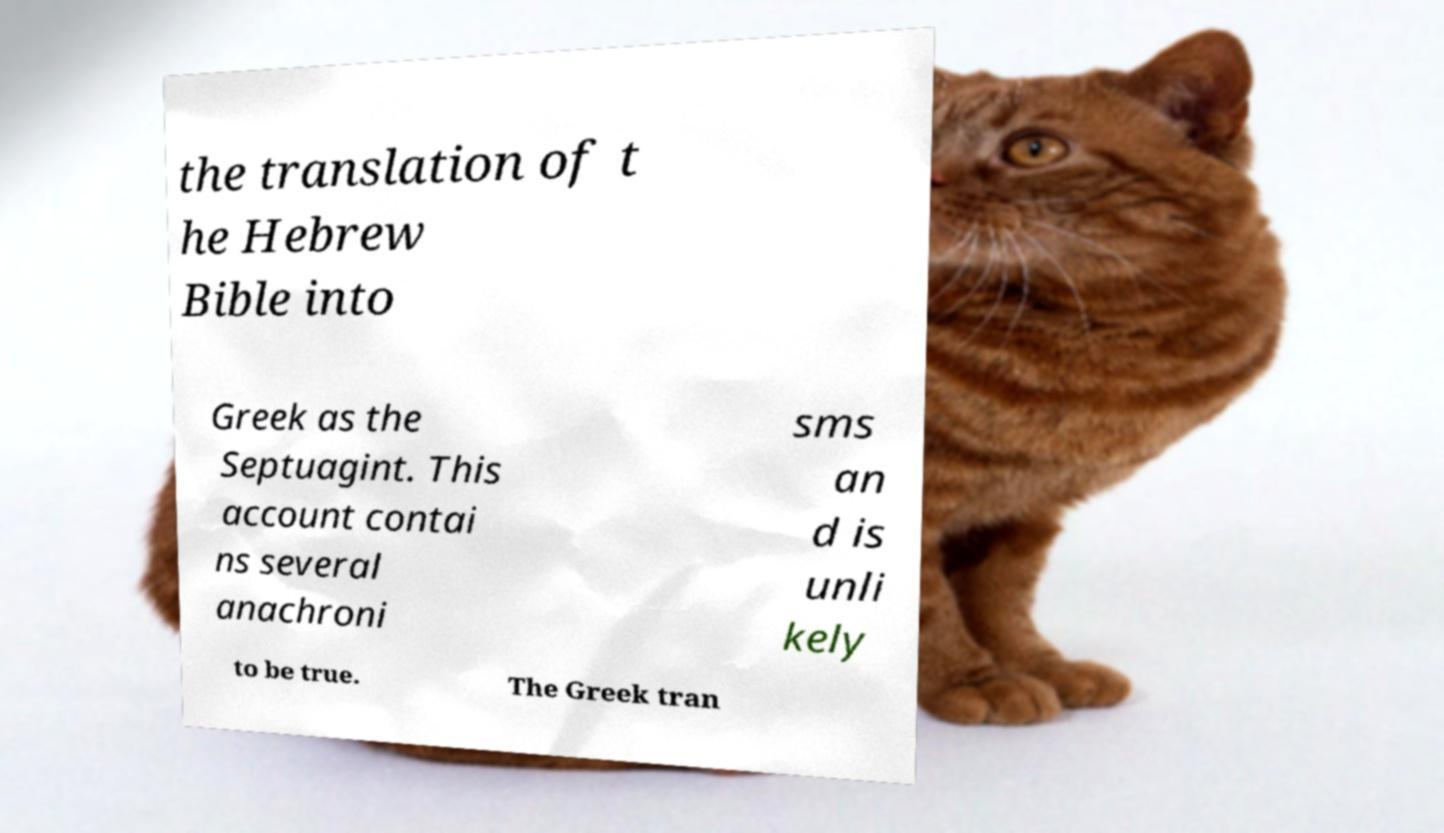For documentation purposes, I need the text within this image transcribed. Could you provide that? the translation of t he Hebrew Bible into Greek as the Septuagint. This account contai ns several anachroni sms an d is unli kely to be true. The Greek tran 